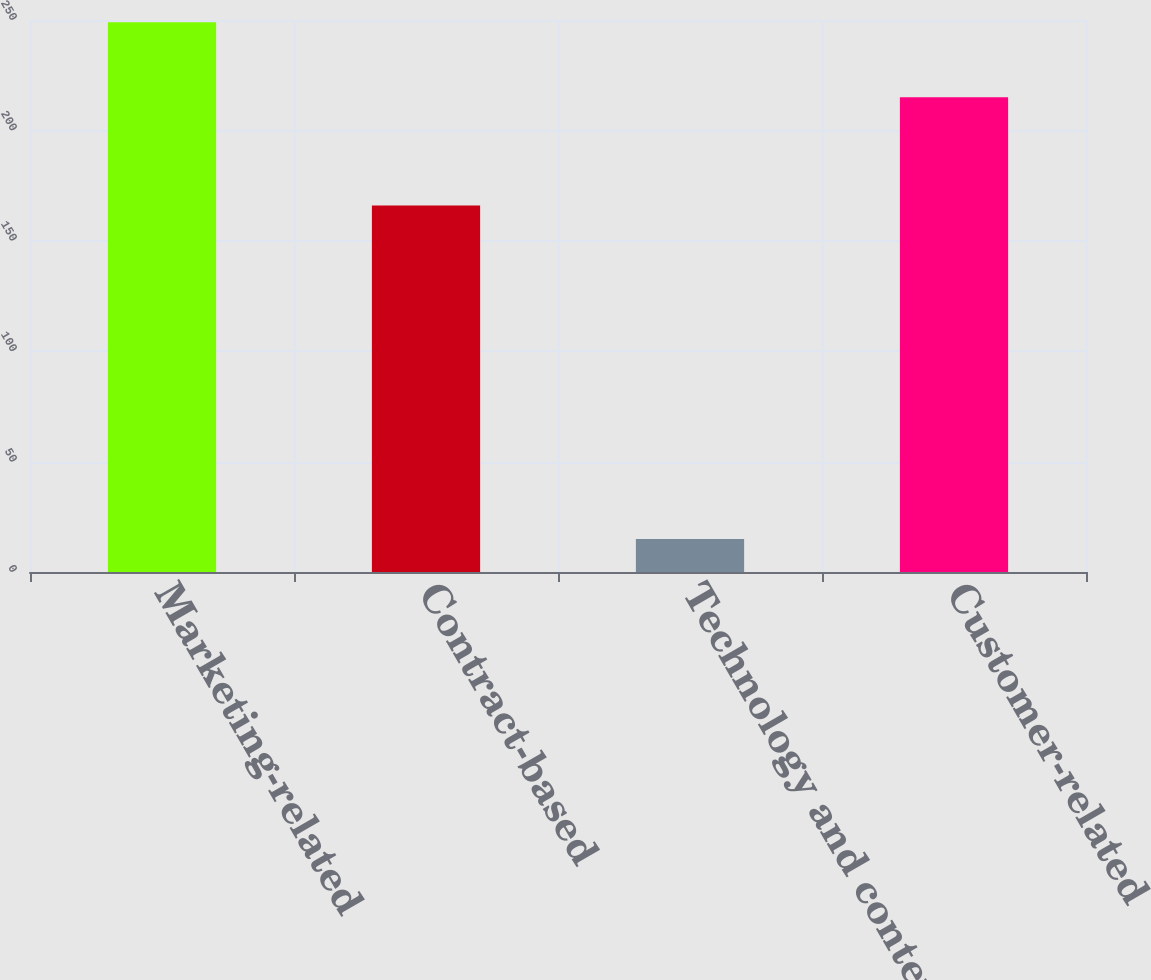Convert chart. <chart><loc_0><loc_0><loc_500><loc_500><bar_chart><fcel>Marketing-related<fcel>Contract-based<fcel>Technology and content<fcel>Customer-related<nl><fcel>249<fcel>166<fcel>15<fcel>215<nl></chart> 